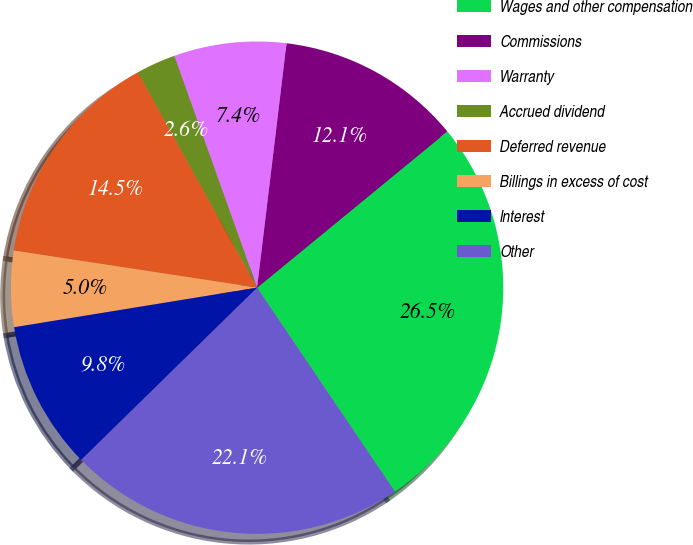<chart> <loc_0><loc_0><loc_500><loc_500><pie_chart><fcel>Wages and other compensation<fcel>Commissions<fcel>Warranty<fcel>Accrued dividend<fcel>Deferred revenue<fcel>Billings in excess of cost<fcel>Interest<fcel>Other<nl><fcel>26.48%<fcel>12.15%<fcel>7.37%<fcel>2.59%<fcel>14.54%<fcel>4.98%<fcel>9.76%<fcel>22.13%<nl></chart> 